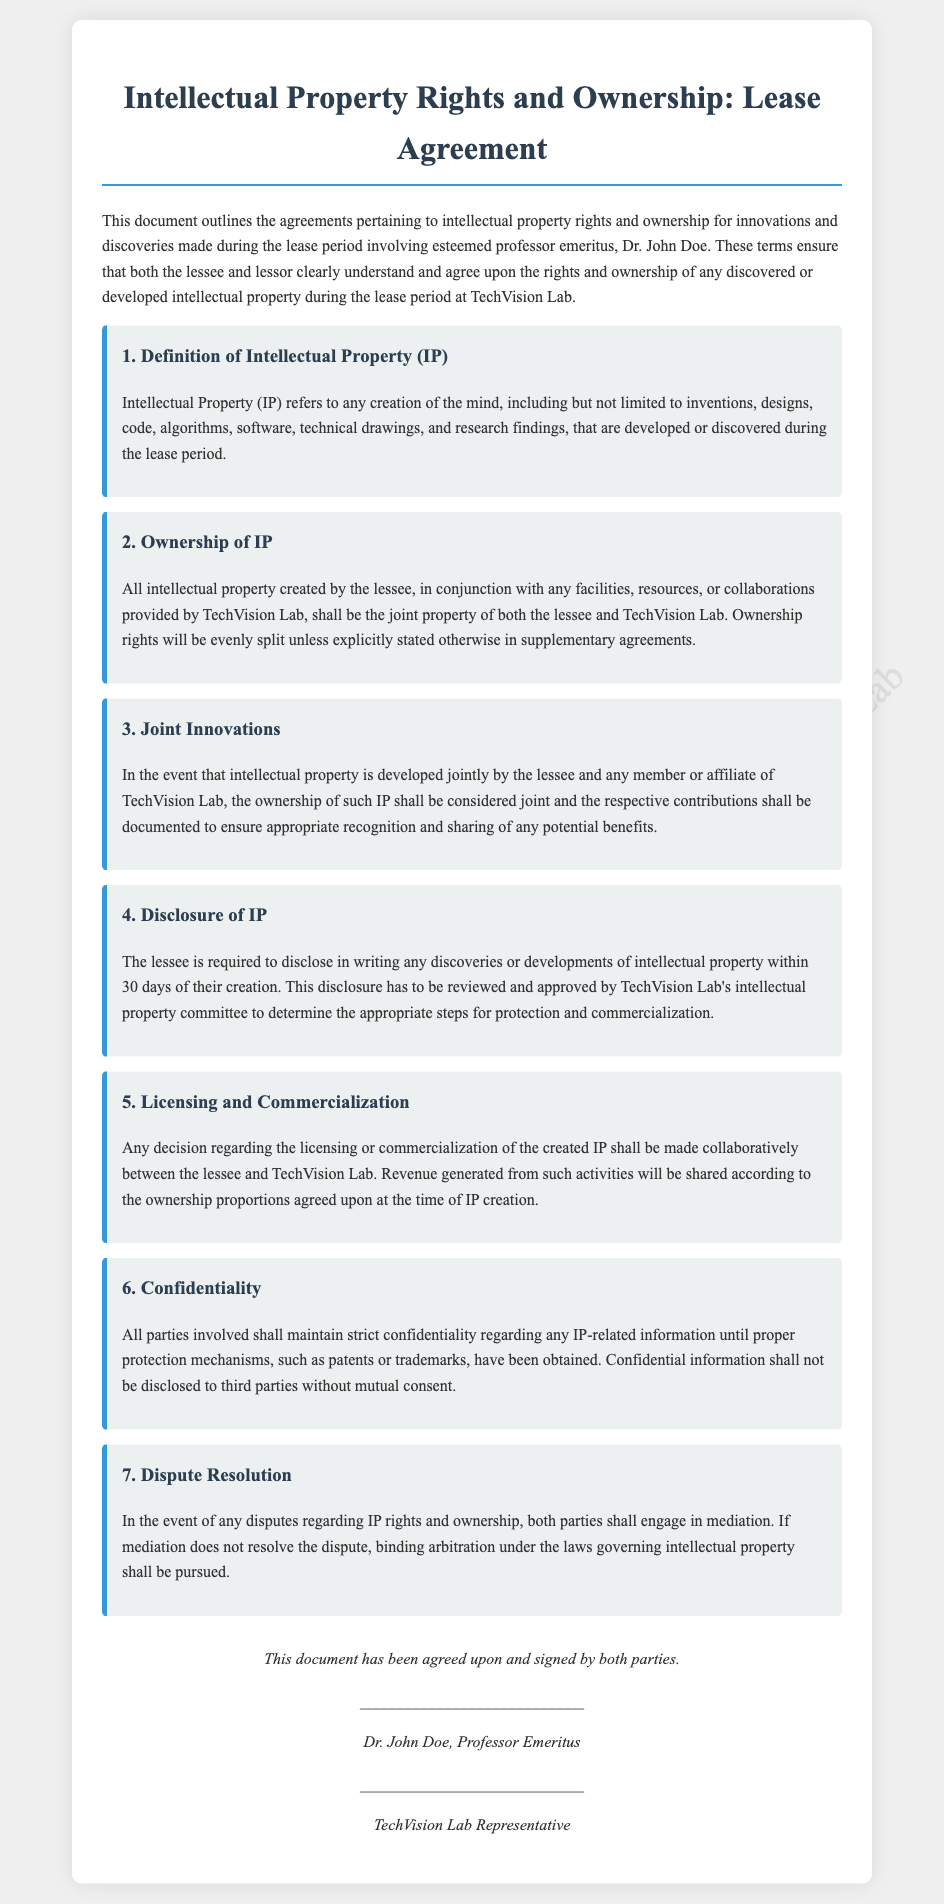What is the title of the document? The title of the document is presented prominently at the top and describes the key subject covered by the document.
Answer: Intellectual Property Rights and Ownership: Lease Agreement Who is the lessee mentioned in the document? The lessee is identified in the introductory paragraph, which states their title and name.
Answer: Dr. John Doe What is defined as Intellectual Property (IP) in the document? The document contains a definition of IP within the first term, detailing its scope.
Answer: Any creation of the mind What is required of the lessee within 30 days of creating IP? The document stipulates an obligation on the lessee regarding the disclosure of IP, detailing timeframes for this action.
Answer: Disclosure in writing How is ownership of jointly developed IP handled? The document outlines ownership protocols for IP developed jointly, highlighting the treatment of contributions.
Answer: Considered joint What must happen if a dispute regarding IP rights arises? The document includes a term addressing disputes and the methods for resolution if issues occur.
Answer: Mediation Who reviews and approves the disclosure of IP? The document specifies a group responsible for reviewing disclosures made by the lessee related to IP.
Answer: TechVision Lab's intellectual property committee What part of the document addresses confidentiality? The document has a specific section that deals with confidentiality regarding IP-related information.
Answer: Confidentiality How will revenue from licensed IP be shared? The document explains profit-sharing from commercialization in a cooperative context to ensure fairness of returns.
Answer: According to the ownership proportions 